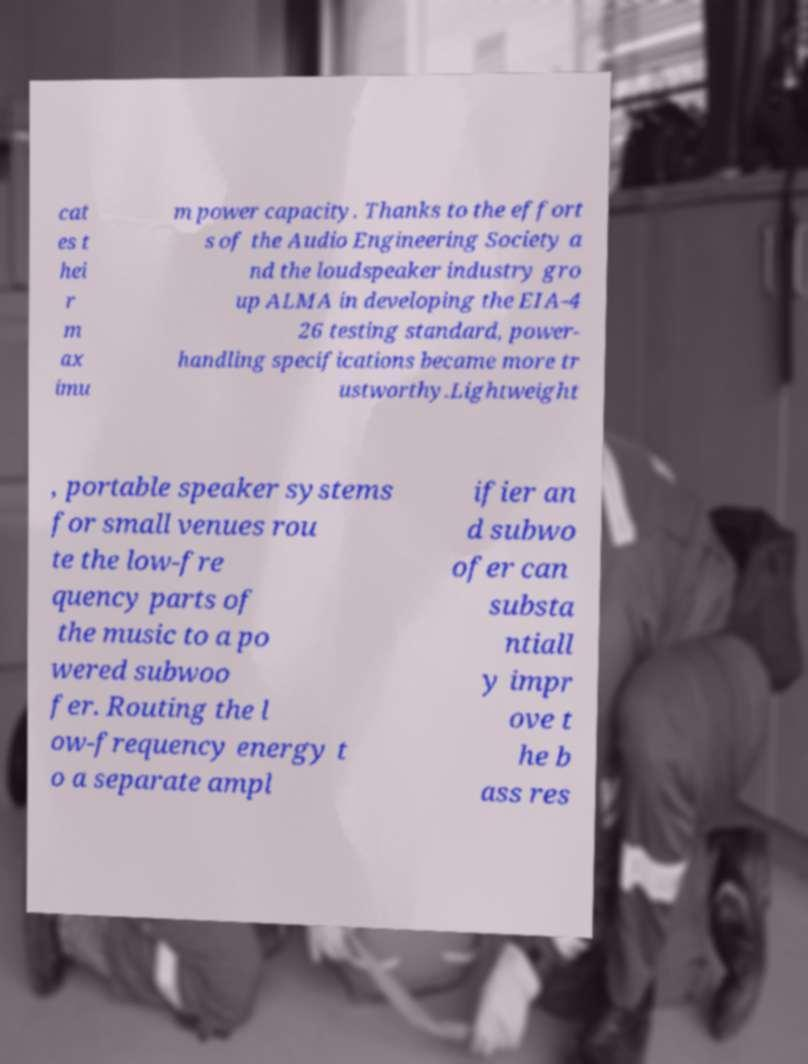What messages or text are displayed in this image? I need them in a readable, typed format. cat es t hei r m ax imu m power capacity. Thanks to the effort s of the Audio Engineering Society a nd the loudspeaker industry gro up ALMA in developing the EIA-4 26 testing standard, power- handling specifications became more tr ustworthy.Lightweight , portable speaker systems for small venues rou te the low-fre quency parts of the music to a po wered subwoo fer. Routing the l ow-frequency energy t o a separate ampl ifier an d subwo ofer can substa ntiall y impr ove t he b ass res 